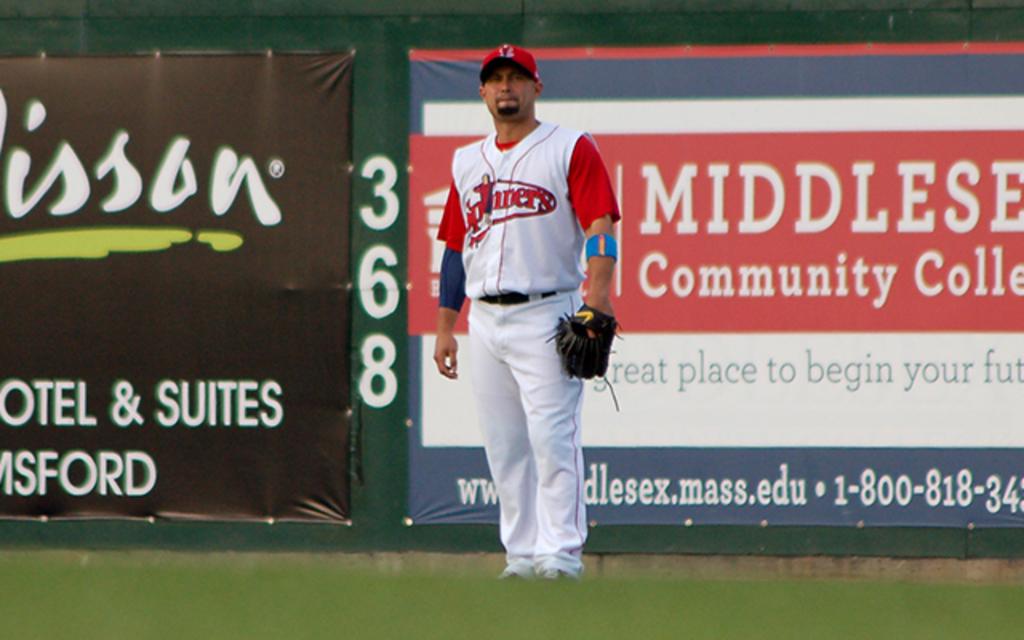What community college advertises at the ball park?
Your answer should be very brief. Middlesex. What numbers are displayed vertically behind the player?
Provide a short and direct response. 368. 